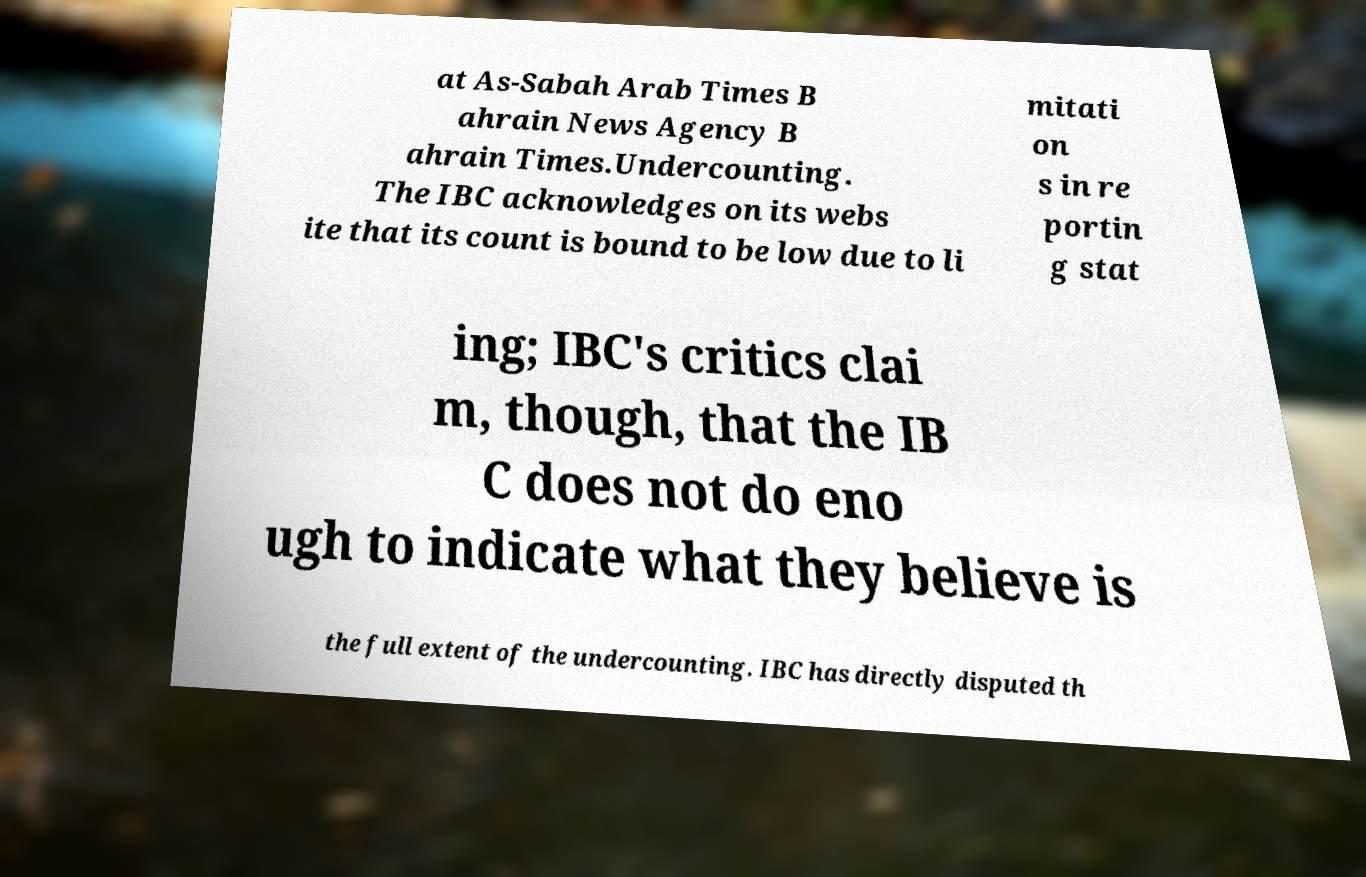For documentation purposes, I need the text within this image transcribed. Could you provide that? at As-Sabah Arab Times B ahrain News Agency B ahrain Times.Undercounting. The IBC acknowledges on its webs ite that its count is bound to be low due to li mitati on s in re portin g stat ing; IBC's critics clai m, though, that the IB C does not do eno ugh to indicate what they believe is the full extent of the undercounting. IBC has directly disputed th 